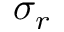Convert formula to latex. <formula><loc_0><loc_0><loc_500><loc_500>\sigma _ { r }</formula> 